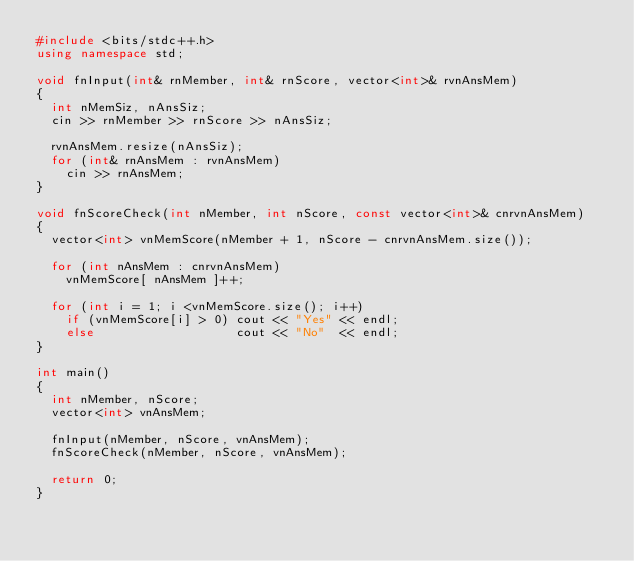<code> <loc_0><loc_0><loc_500><loc_500><_C++_>#include <bits/stdc++.h>
using namespace std;

void fnInput(int& rnMember, int& rnScore, vector<int>& rvnAnsMem)
{
  int nMemSiz, nAnsSiz;
  cin >> rnMember >> rnScore >> nAnsSiz;

  rvnAnsMem.resize(nAnsSiz);
  for (int& rnAnsMem : rvnAnsMem)
    cin >> rnAnsMem;
}

void fnScoreCheck(int nMember, int nScore, const vector<int>& cnrvnAnsMem)
{
  vector<int> vnMemScore(nMember + 1, nScore - cnrvnAnsMem.size());

  for (int nAnsMem : cnrvnAnsMem)
    vnMemScore[ nAnsMem ]++;

  for (int i = 1; i <vnMemScore.size(); i++)
    if (vnMemScore[i] > 0) cout << "Yes" << endl;
    else                   cout << "No"  << endl;
}

int main()
{
  int nMember, nScore;
  vector<int> vnAnsMem;

  fnInput(nMember, nScore, vnAnsMem);
  fnScoreCheck(nMember, nScore, vnAnsMem);

  return 0;
}</code> 